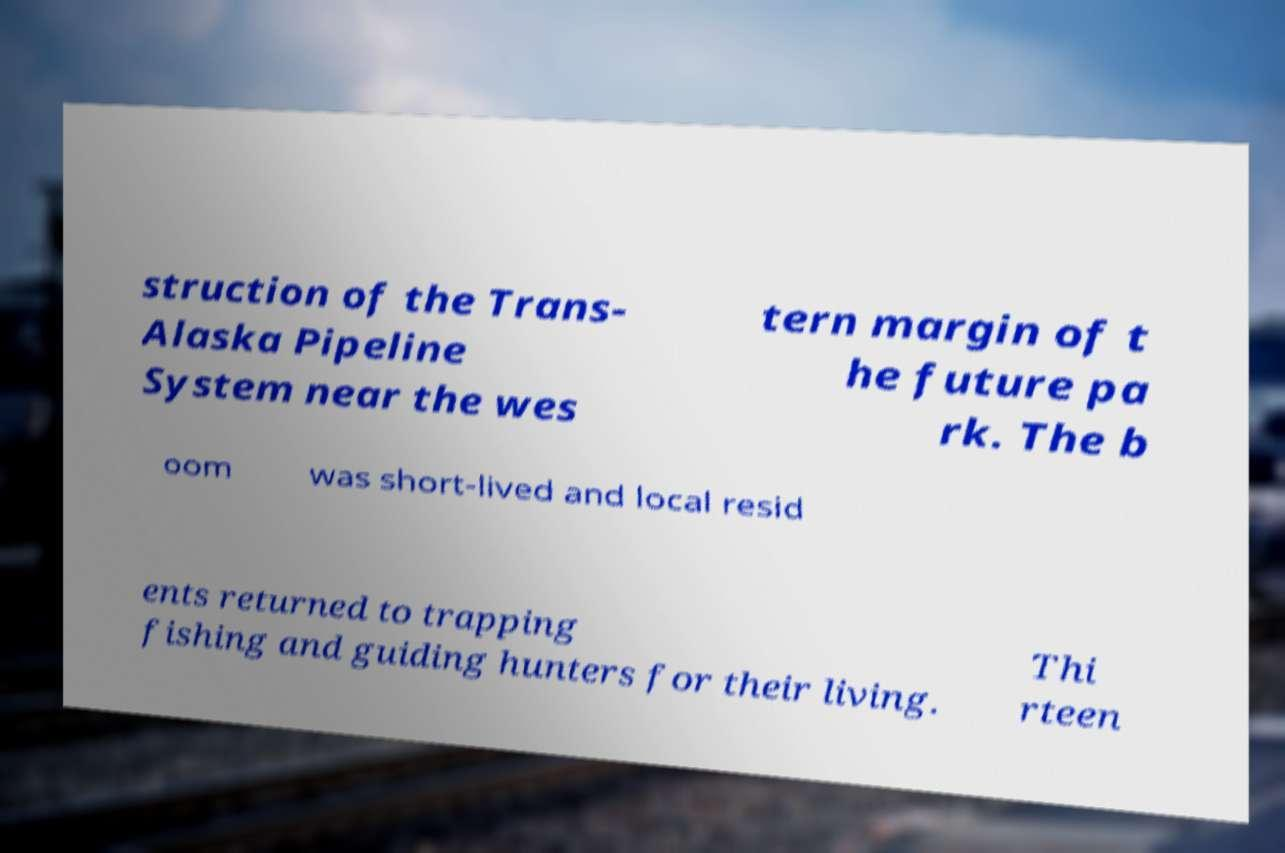Please read and relay the text visible in this image. What does it say? struction of the Trans- Alaska Pipeline System near the wes tern margin of t he future pa rk. The b oom was short-lived and local resid ents returned to trapping fishing and guiding hunters for their living. Thi rteen 